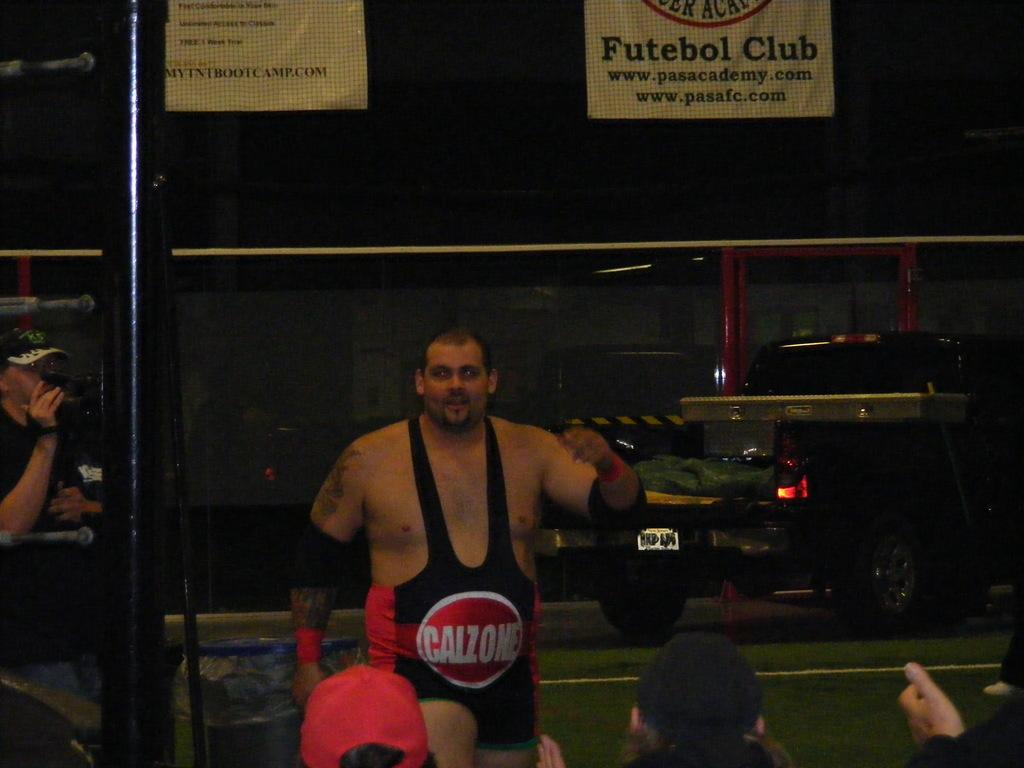<image>
Render a clear and concise summary of the photo. Wrestler wearing black tights that say Calzone on it. 